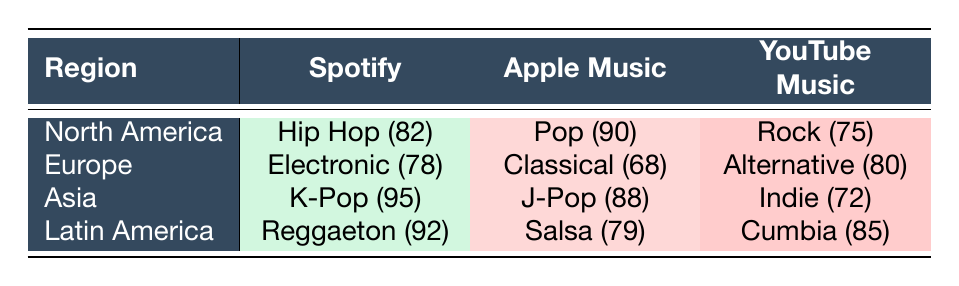What is the most popular genre in North America on Spotify? The table shows that the genre for North America on Spotify is Hip Hop with a popularity score of 82. Therefore, it is the most popular genre in that region for that app.
Answer: Hip Hop Which app features Electronic music in Europe? The table indicates that Spotify features Electronic music in Europe, with a popularity score of 78.
Answer: Spotify Is Pop the most popular genre on Apple Music in North America? According to the table, Pop has a popularity score of 90 on Apple Music in North America, which is indeed the highest score in that region for that app. So, yes, it is the most popular genre on Apple Music in North America.
Answer: Yes What is the average popularity score for genres listed under YouTube Music? To calculate the average popularity score for YouTube Music, we take the scores of the genres: Rock (75), Alternative (80), Indie (72), and Cumbia (85). The sum is 75 + 80 + 72 + 85 = 312, and there are 4 genres, so the average score is 312/4 = 78.
Answer: 78 Which genre has the highest popularity score in Asia, and on which app? The highest popularity score in Asia is 95 for the genre K-Pop on Spotify. This can be confirmed by reviewing the Asia row in the table.
Answer: K-Pop on Spotify Is Reggaeton more popular than Salsa in Latin America? The table shows that Reggaeton has a popularity score of 92 while Salsa has a score of 79, so Reggaeton is indeed more popular than Salsa in Latin America.
Answer: Yes Which genre in Latin America has the lowest popularity score, and what is that score? By reviewing the Latin America row in the table, Salsa has the lowest score of 79 among the listed genres.
Answer: Salsa, 79 What is the difference between the popularity scores of Hip Hop and Reggaeton? The popularity score for Hip Hop is 82 and for Reggaeton is 92. The difference can be calculated as 92 - 82 = 10.
Answer: 10 Which app has the highest popularity score for Classical music in Europe? The table indicates that Apple Music features Classical music with a popularity score of 68, which is the only score for this genre in Europe, making it the highest for that app.
Answer: Apple Music, 68 